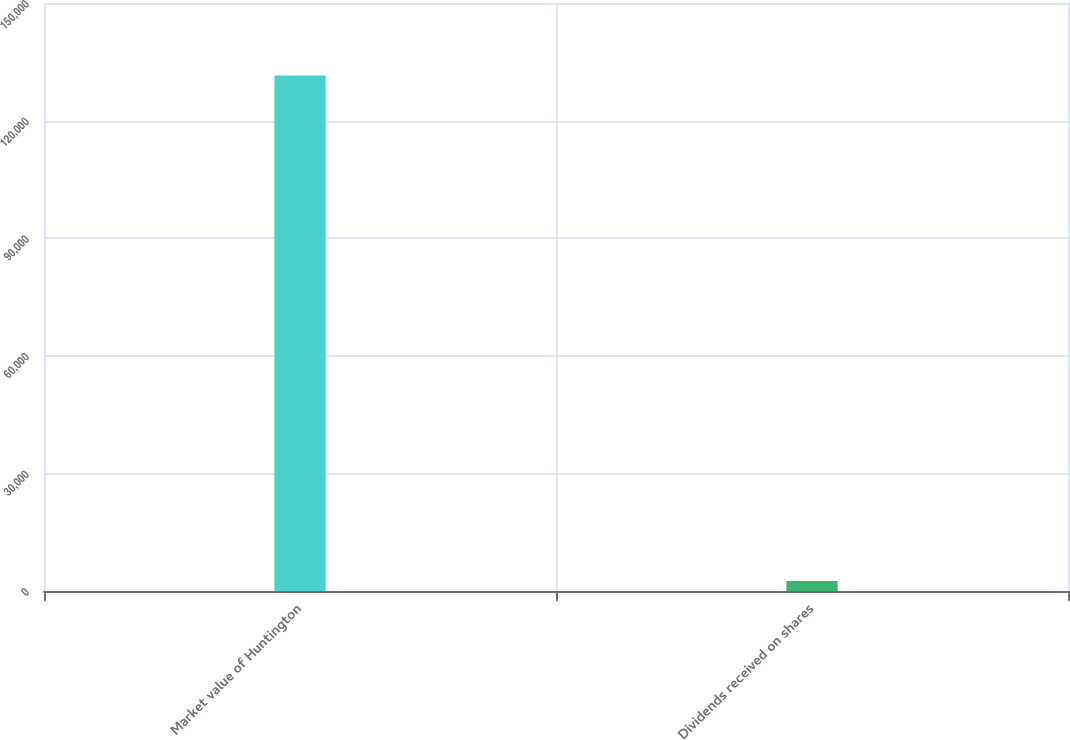<chart> <loc_0><loc_0><loc_500><loc_500><bar_chart><fcel>Market value of Huntington<fcel>Dividends received on shares<nl><fcel>131476<fcel>2567<nl></chart> 